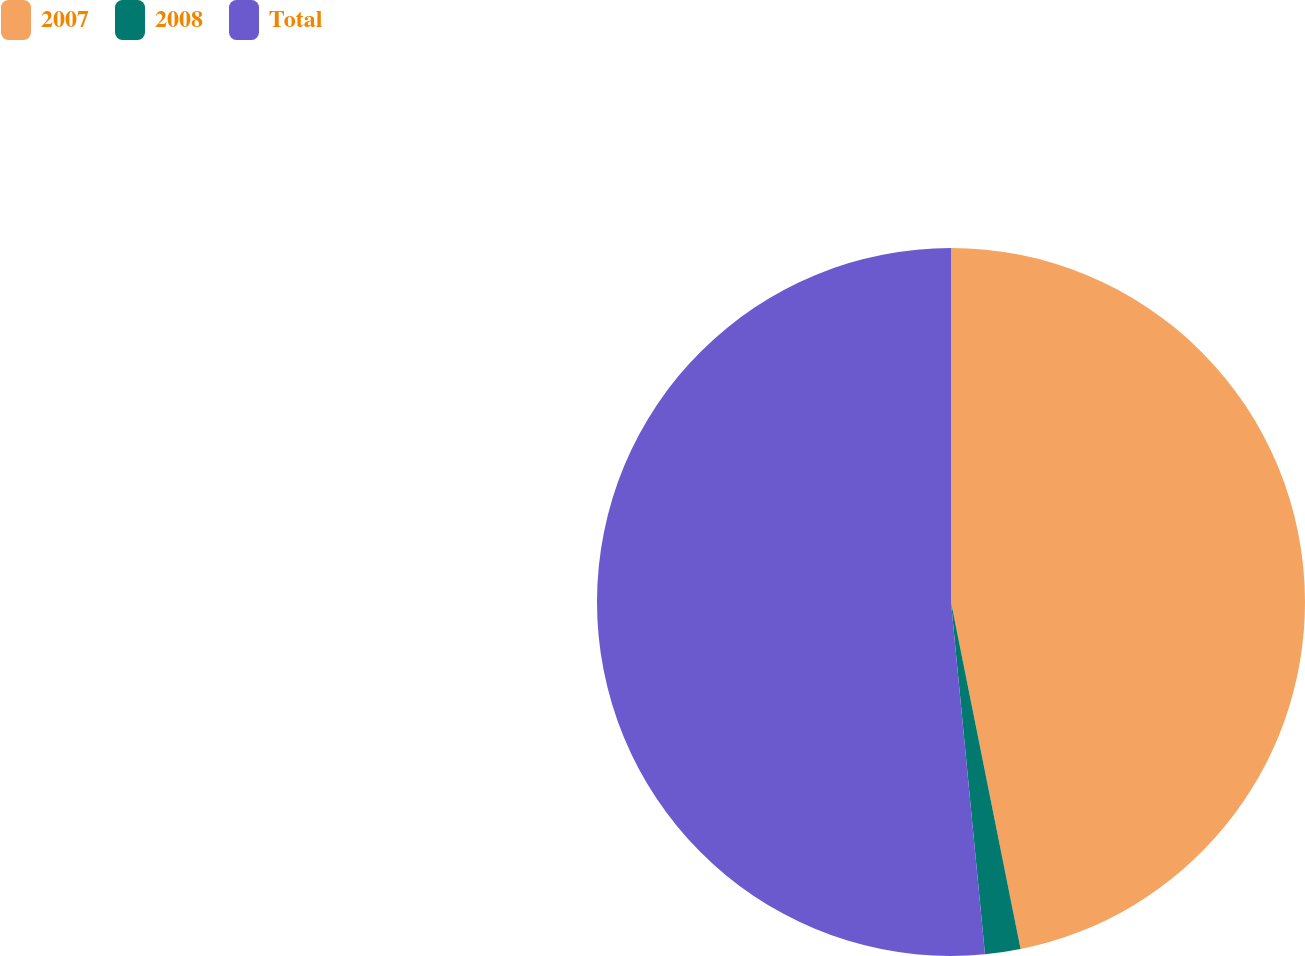Convert chart to OTSL. <chart><loc_0><loc_0><loc_500><loc_500><pie_chart><fcel>2007<fcel>2008<fcel>Total<nl><fcel>46.85%<fcel>1.62%<fcel>51.53%<nl></chart> 